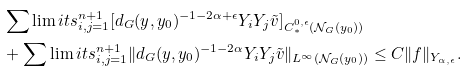<formula> <loc_0><loc_0><loc_500><loc_500>& \sum \lim i t s _ { i , j = 1 } ^ { n + 1 } [ d _ { G } ( y , y _ { 0 } ) ^ { - 1 - 2 \alpha + \epsilon } Y _ { i } Y _ { j } \tilde { v } ] _ { C ^ { 0 , \epsilon } _ { \ast } ( \mathcal { N } _ { G } ( y _ { 0 } ) ) } \\ & + \sum \lim i t s _ { i , j = 1 } ^ { n + 1 } \| d _ { G } ( y , y _ { 0 } ) ^ { - 1 - 2 \alpha } Y _ { i } Y _ { j } \tilde { v } \| _ { L ^ { \infty } ( \mathcal { N } _ { G } ( y _ { 0 } ) ) } \leq C \| f \| _ { Y _ { \alpha , \epsilon } } .</formula> 